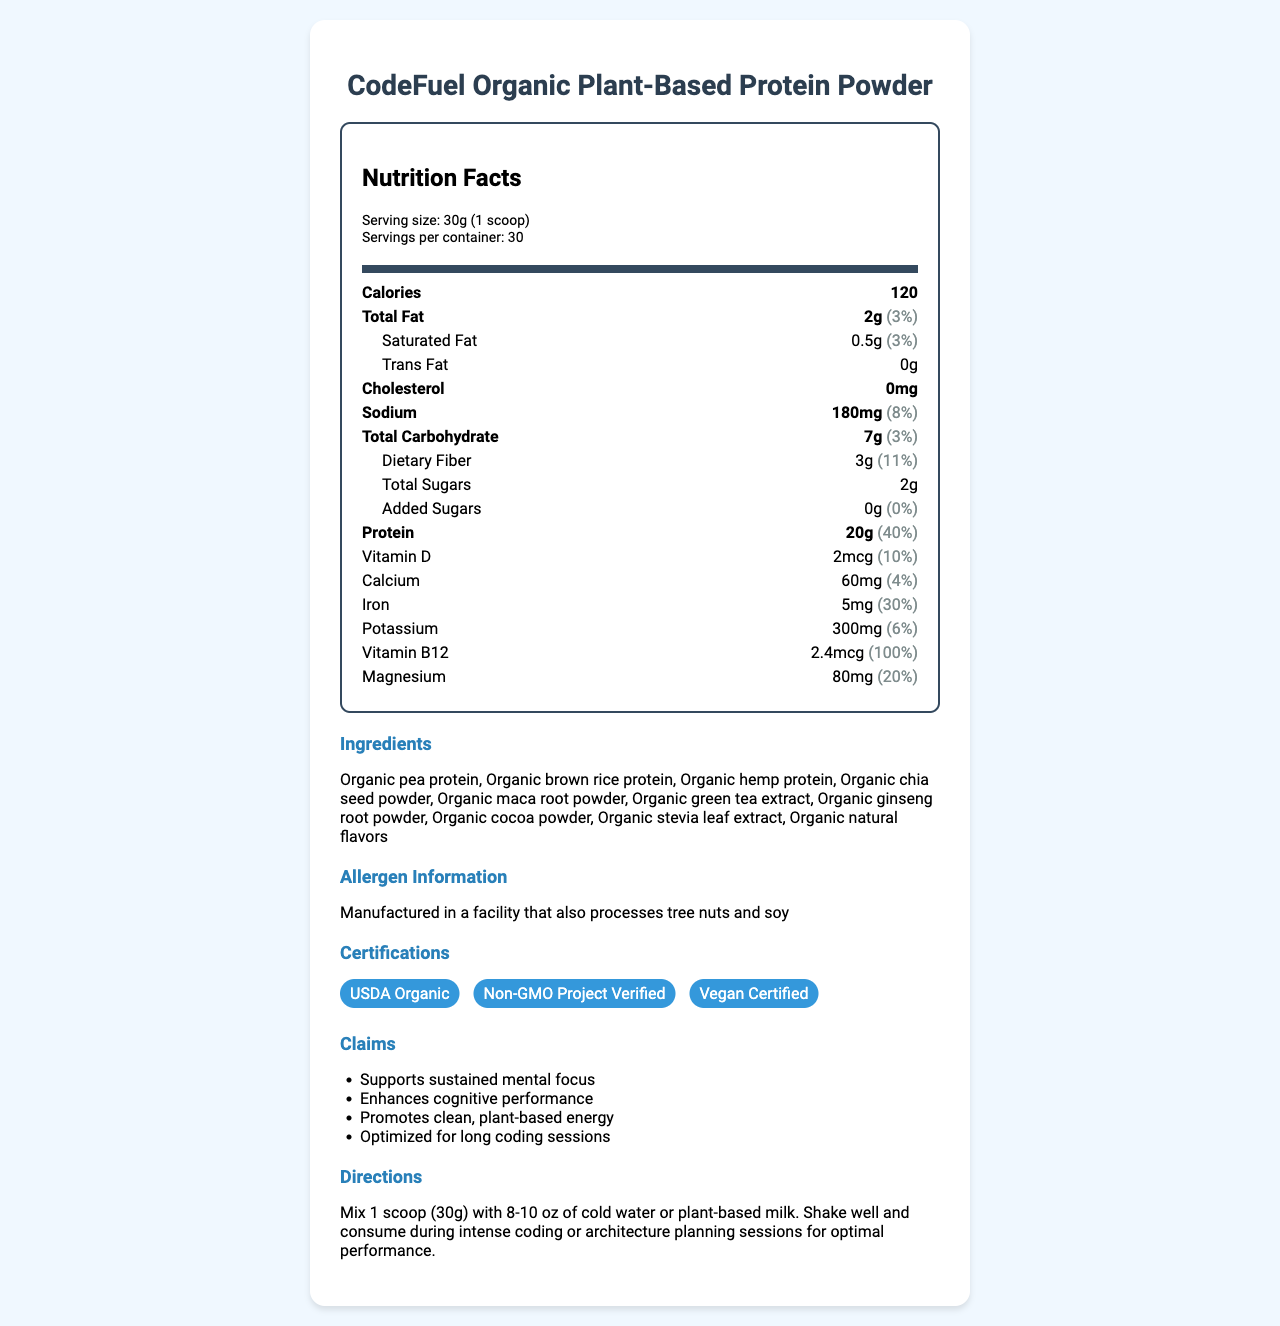What is the serving size of CodeFuel Organic Plant-Based Protein Powder? The serving size is mentioned under the serving information: "Serving size: 30g (1 scoop)."
Answer: 30g (1 scoop) How many calories are there per serving? The calories per serving are listed as: "Calories: 120."
Answer: 120 What is the amount of protein in each serving? The document shows the protein amount in the nutrient section, which states "Protein: 20g."
Answer: 20g What is the daily value percentage of vitamin B12? The daily value for vitamin B12 is listed under the vitamin section as "Vitamin B12: 100%."
Answer: 100% Does this product contain any trans fat? The document explicitly mentions under trans fat: "Trans Fat: 0g."
Answer: No How many servings are there per container? The servings per container are listed as: "Servings per container: 30."
Answer: 30 What is the ingredient with the highest content in the protein powder? The ingredients are listed in order of content, the first being "Organic pea protein."
Answer: Organic pea protein How much dietary fiber does each serving contain? The dietary fiber content per serving is listed under carbohydrates as "Dietary Fiber: 3g."
Answer: 3g Which of the following certifications does CodeFuel Organic Plant-Based Protein Powder have? A. Non-GMO Project Verified B. Certified Gluten-Free C. USDA Organic D. Vegan Certified The document lists certifications: "USDA Organic, Non-GMO Project Verified, Vegan Certified."
Answer: A, C, D What is the sodium content per serving and its daily value percentage? A. 180mg, 8% B. 120mg, 5% C. 200mg, 9% The sodium content is noted as "Sodium: 180mg (8%)".
Answer: A. 180mg, 8% Is the product optimized for long coding sessions? The claim section states: "Optimized for long coding sessions."
Answer: Yes Summarize the key points of the nutrition facts label for CodeFuel Organic Plant-Based Protein Powder. The summary includes key nutritional components, ingredients, certifications, and claims about the product's benefits.
Answer: The label shows that each serving (30g) of CodeFuel provides 120 calories with 2g total fat, 7g carbs, 3g dietary fiber, and 20g protein. Notable nutrients include vitamin B12 (100% DV) and iron (30% DV). The product contains organic ingredients and has certifications such as USDA Organic, Non-GMO Project Verified, and Vegan Certified, claiming to support sustained mental focus and energy for long coding sessions. Does this product contain any added sugars? The nutrition label states: "Added Sugars: 0g."
Answer: No What are the health claims mentioned about the product? The claims section lists these specific health benefits.
Answer: Supports sustained mental focus, Enhances cognitive performance, Promotes clean, plant-based energy, Optimized for long coding sessions In which facility is the product manufactured? The document mentions the allergens but does not specify the exact facility of manufacture.
Answer: Cannot be determined 